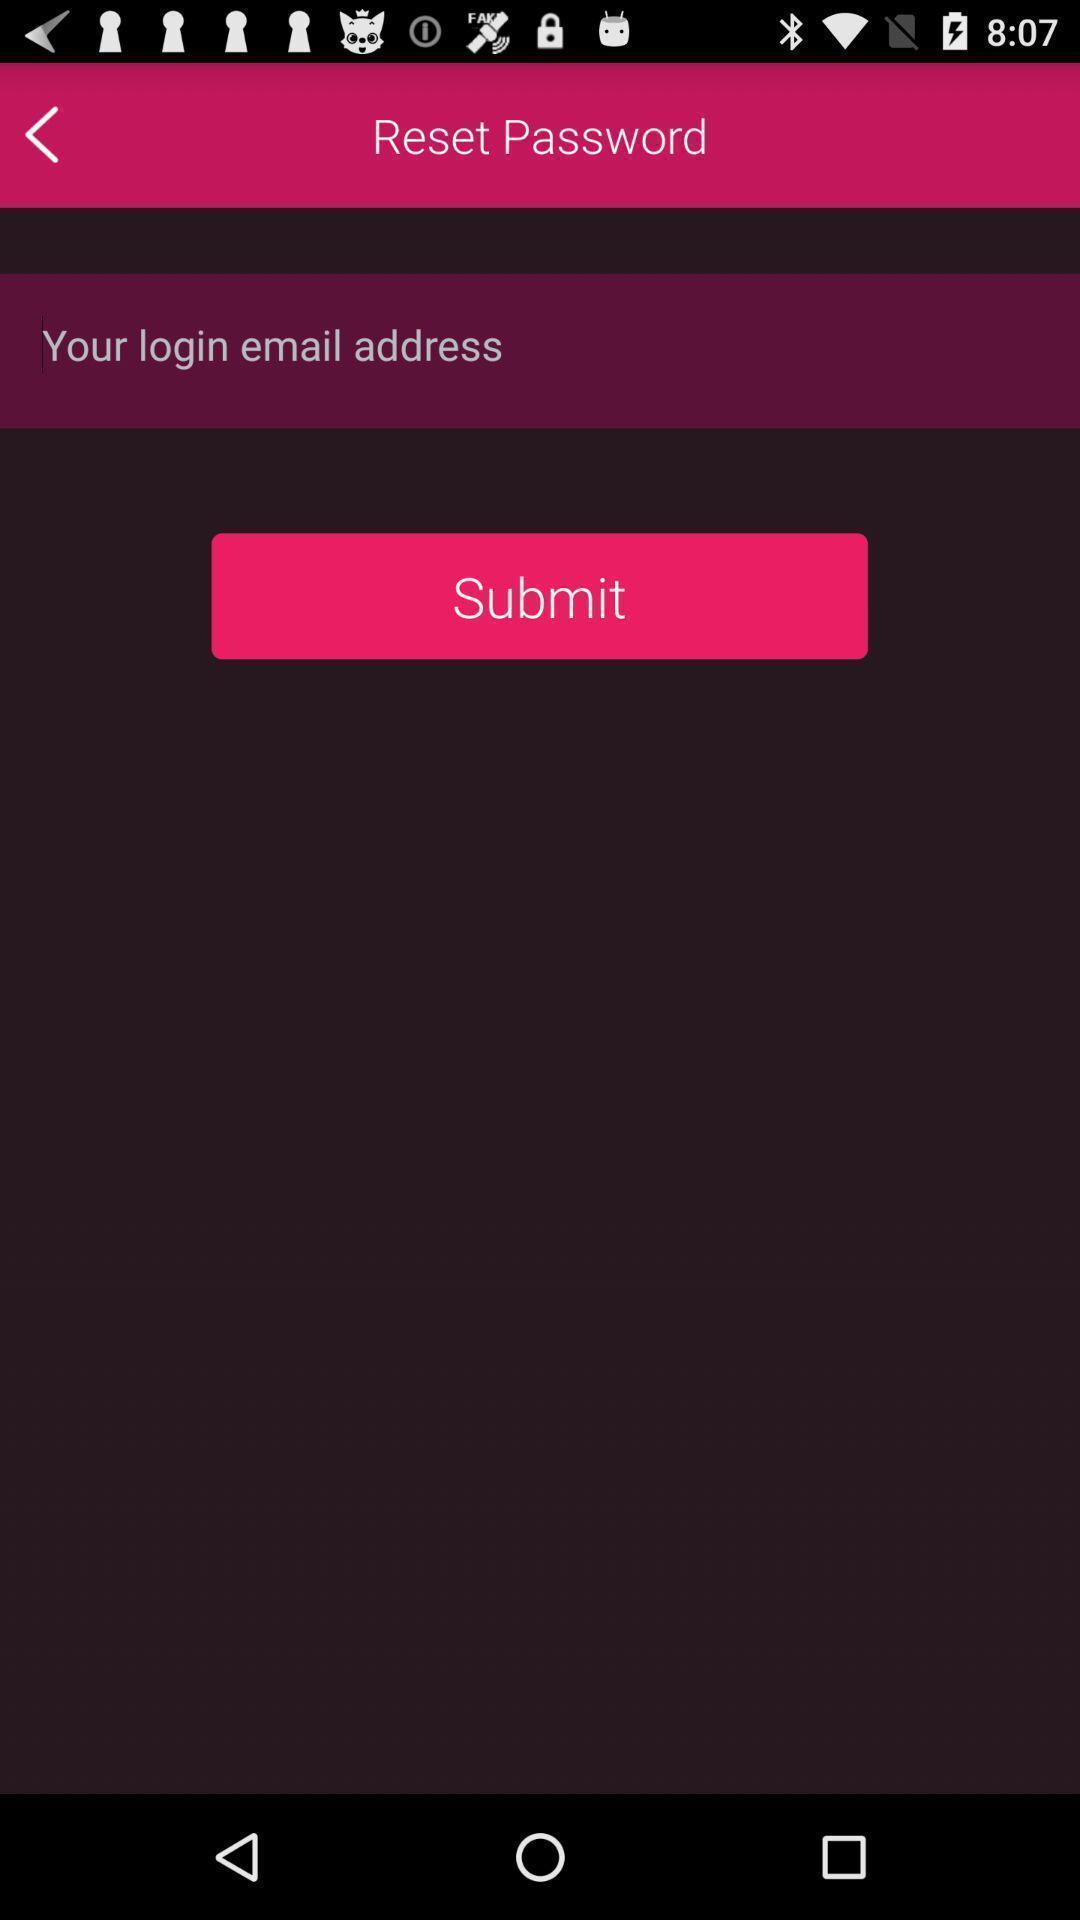Provide a description of this screenshot. Reset password page of a dating app. 